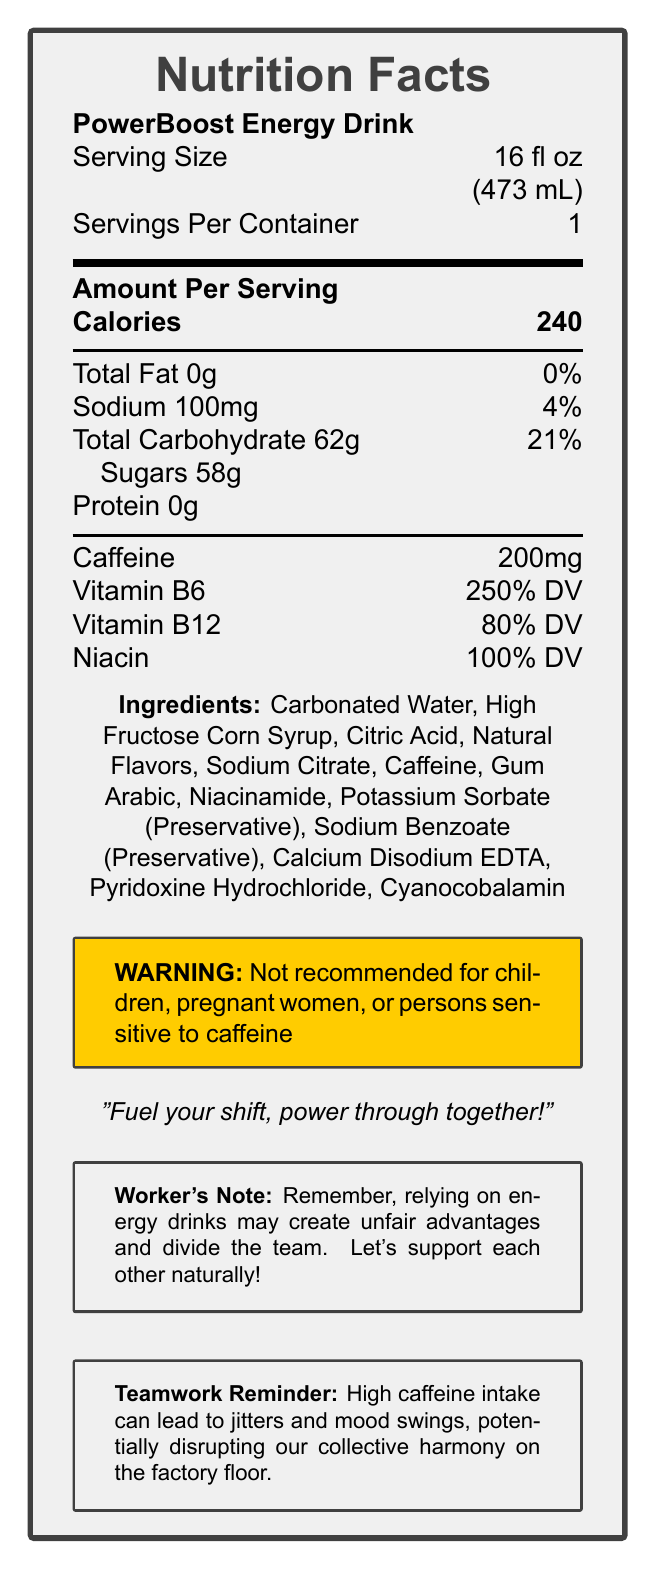what is the serving size of PowerBoost Energy Drink? The serving size is listed at the top of the Nutrition Facts, under the product name.
Answer: 16 fl oz (473 mL) how many calories are there in one serving? The number of calories per serving is prominently displayed in the "Amount Per Serving" section.
Answer: 240 how much caffeine is in one serving? The document lists the caffeine content as 200mg in the nutrient values section.
Answer: 200mg what is the total carbohydrate content? Total Carbohydrate content is listed as 62g in the nutrient values section.
Answer: 62g name one ingredient in PowerBoost Energy Drink. The ingredients are listed toward the bottom and carbonated water is the first one.
Answer: Carbonated Water what percentage of the daily value of Vitamin B6 does this drink provide? A. 100% B. 150% C. 250% D. 300% The document states that the drink provides 250% of the daily value for Vitamin B6.
Answer: C which nutrient has the highest daily value percentage: Vitamin B6, Vitamin B12, or Niacin? The document shows Vitamin B6 at 250%, Vitamin B12 at 80%, and Niacin at 100%.
Answer: Vitamin B6 is this drink recommended for children? The warning box clearly states that it is not recommended for children.
Answer: No summarize the key nutritional points of PowerBoost Energy Drink. The document highlights the high sugar and caffeine content along with significant daily values for certain vitamins.
Answer: PowerBoost Energy Drink provides high sugar (58g) and caffeine (200mg) content per 16 fl oz serving, with vitamins B6, B12, and Niacin. what does the teamwork reminder emphasize? The teamwork reminder box at the bottom of the document states this point.
Answer: High caffeine intake can lead to jitters and mood swings, potentially disrupting collective harmony. how is the company slogan relevant to factory workers? The slogan implies that the energy drink is meant to help workers power through their shifts together.
Answer: Fuel your shift, power through together! what is the sodium content in one serving? The sodium content is listed in the nutrient values as 100mg.
Answer: 100mg what is the purpose of the worker's note? The worker's note explicitly points out potential issues regarding fairness and teamwork.
Answer: To remind workers that relying on energy drinks may create unfair advantages and divide the team. how much protein is in PowerBoost Energy Drink? The protein content is listed as 0g in the nutrient values.
Answer: 0g what are the preservatives in this drink? These ingredients are listed under the "Ingredients" section.
Answer: Potassium Sorbate, Sodium Benzoate, Calcium Disodium EDTA does the drink include artificial colors? The document lists several ingredients but does not specify whether artificial colors are included.
Answer: Not enough information how many grams of sugars are there in one serving? The sugar content is listed under the total carbohydrate section as 58g.
Answer: 58g how many servings per container does PowerBoost Energy Drink have? The document states "1" under the servings per container.
Answer: 1 identify a potential effect of high caffeine intake mentioned in the document. The teamwork reminder at the bottom mentions these potential effects of high caffeine intake.
Answer: Jitters and mood swings how does the document address the fairness issue concerning energy drinks and teamwork? The worker's note specifically addresses this concern.
Answer: It mentions that relying on energy drinks may create unfair advantages and divide the team. 